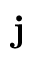Convert formula to latex. <formula><loc_0><loc_0><loc_500><loc_500>\mathbf j</formula> 